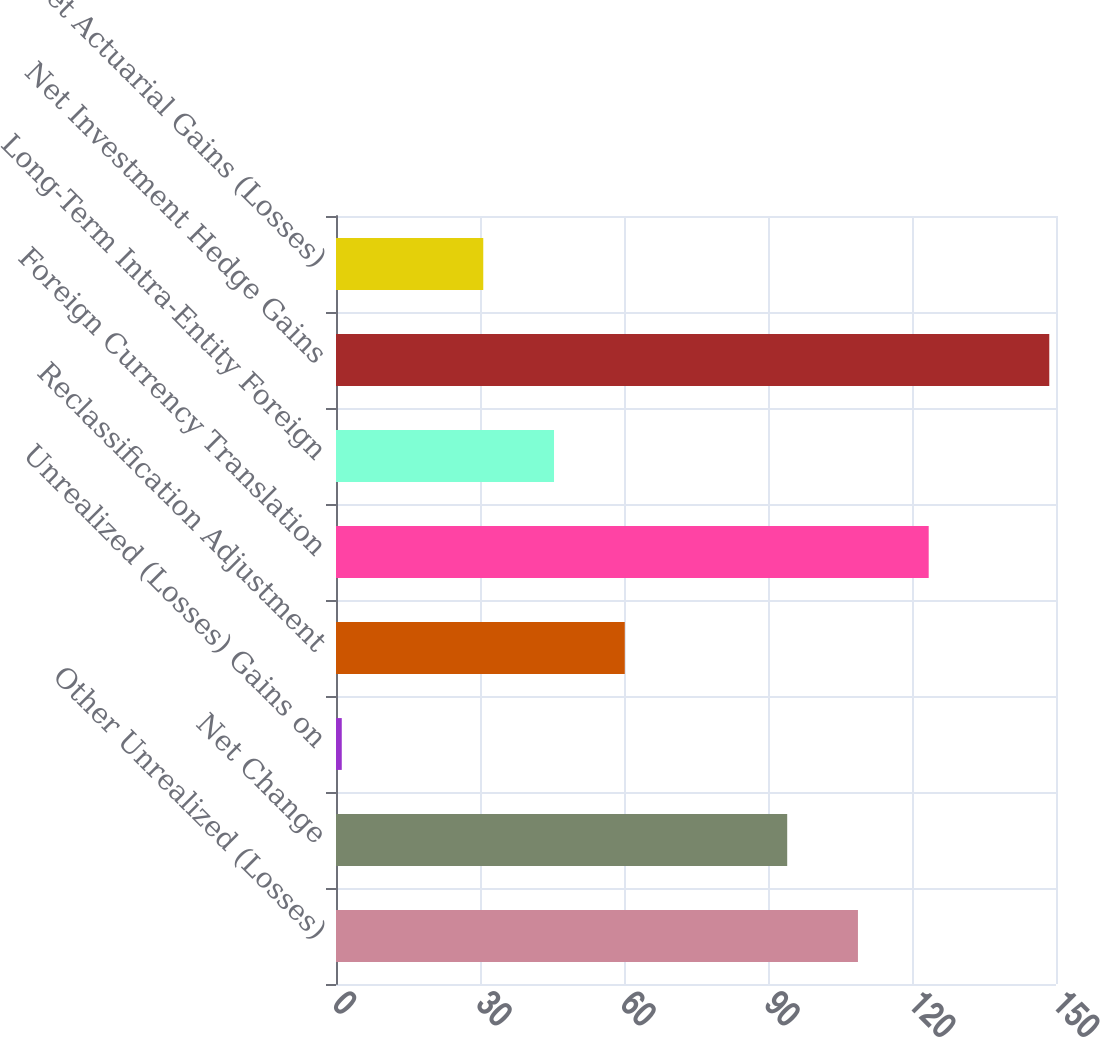<chart> <loc_0><loc_0><loc_500><loc_500><bar_chart><fcel>Other Unrealized (Losses)<fcel>Net Change<fcel>Unrealized (Losses) Gains on<fcel>Reclassification Adjustment<fcel>Foreign Currency Translation<fcel>Long-Term Intra-Entity Foreign<fcel>Net Investment Hedge Gains<fcel>Net Actuarial Gains (Losses)<nl><fcel>108.74<fcel>94<fcel>1.2<fcel>60.16<fcel>123.48<fcel>45.42<fcel>148.6<fcel>30.68<nl></chart> 